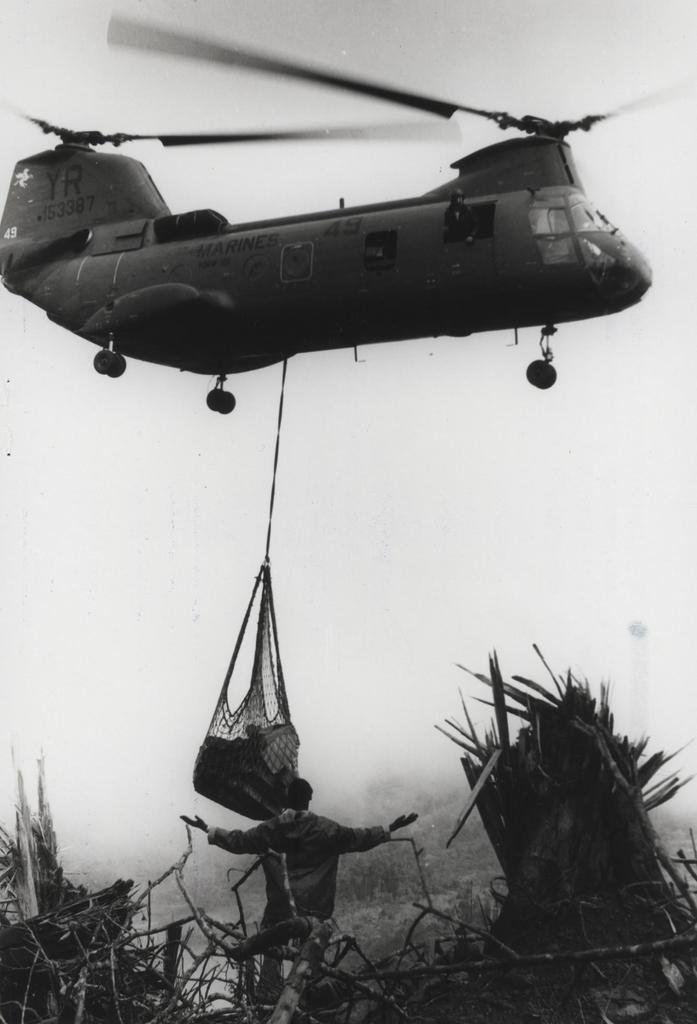What is the color scheme of the image? The image is black and white. What is the main subject in the image? There is an aircraft in the image. How is the aircraft positioned in the image? The aircraft is hanging in the image. What else is hanging with the aircraft? There are items hanging with the aircraft. What can be seen at the bottom of the image? There are objects at the bottom of the image. Are there any people in the image? Yes, there is a man in the image. What type of jewel is the man wearing in the image? There is no mention of a jewel in the image, and the man is not depicted as wearing any jewelry. 